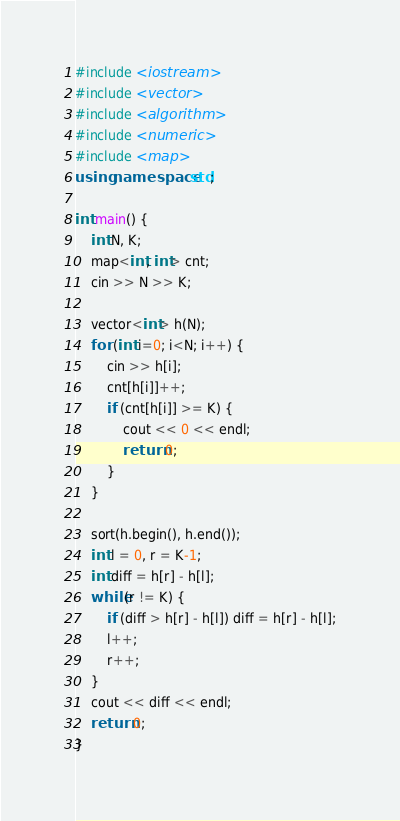<code> <loc_0><loc_0><loc_500><loc_500><_C++_>#include <iostream>
#include <vector>
#include <algorithm>
#include <numeric>
#include <map>
using namespace std;

int main() {
    int N, K;
    map<int, int> cnt;
    cin >> N >> K;

    vector<int> h(N);
    for (int i=0; i<N; i++) {
        cin >> h[i];
        cnt[h[i]]++;
        if (cnt[h[i]] >= K) {
            cout << 0 << endl;
            return 0;
        }
    }

    sort(h.begin(), h.end());
    int l = 0, r = K-1;
    int diff = h[r] - h[l];
    while(r != K) {
        if (diff > h[r] - h[l]) diff = h[r] - h[l];
        l++;
        r++;
    }
    cout << diff << endl;
    return 0;
}</code> 